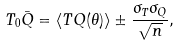Convert formula to latex. <formula><loc_0><loc_0><loc_500><loc_500>T _ { 0 } \bar { Q } = \langle T Q ( \theta ) \rangle \pm \frac { \sigma _ { T } \sigma _ { Q } } { \sqrt { n } } ,</formula> 